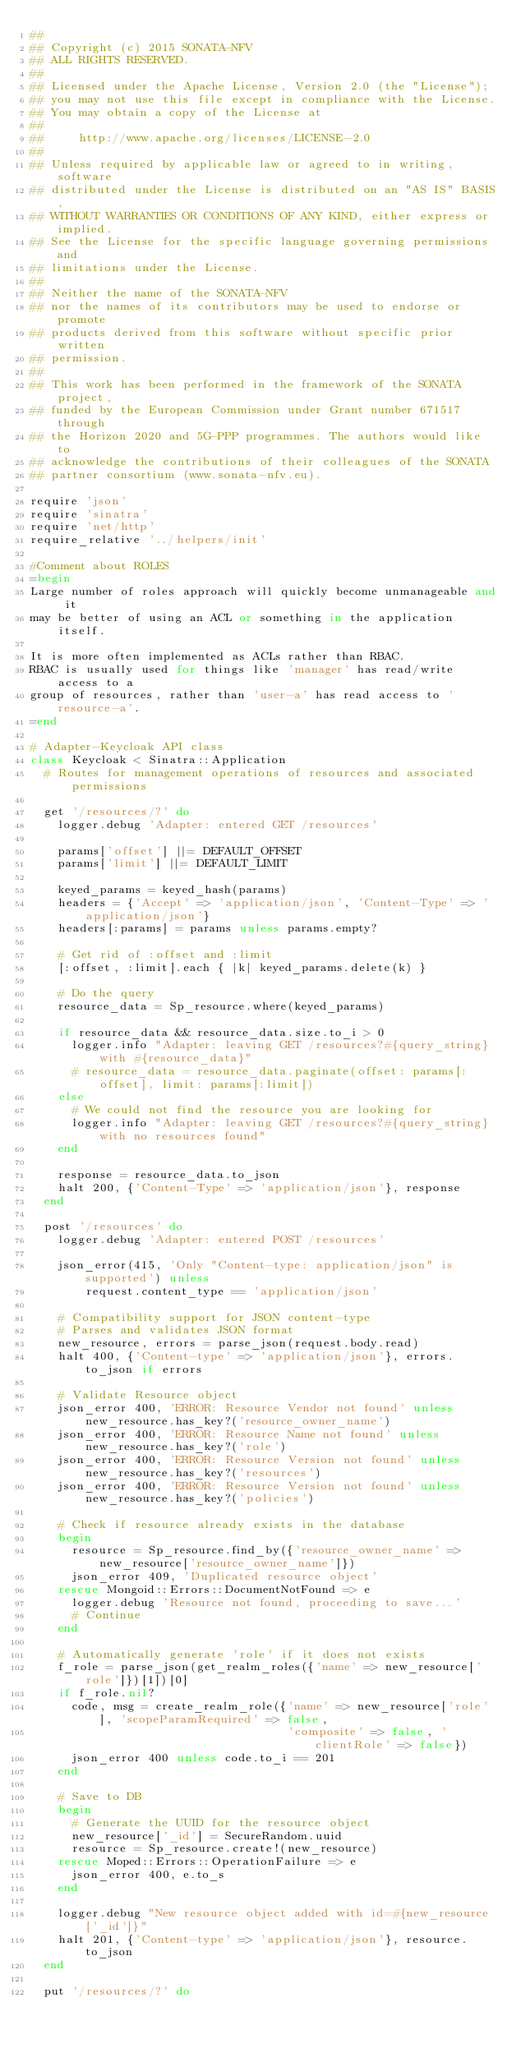<code> <loc_0><loc_0><loc_500><loc_500><_Ruby_>##
## Copyright (c) 2015 SONATA-NFV
## ALL RIGHTS RESERVED.
##
## Licensed under the Apache License, Version 2.0 (the "License");
## you may not use this file except in compliance with the License.
## You may obtain a copy of the License at
##
##     http://www.apache.org/licenses/LICENSE-2.0
##
## Unless required by applicable law or agreed to in writing, software
## distributed under the License is distributed on an "AS IS" BASIS,
## WITHOUT WARRANTIES OR CONDITIONS OF ANY KIND, either express or implied.
## See the License for the specific language governing permissions and
## limitations under the License.
##
## Neither the name of the SONATA-NFV
## nor the names of its contributors may be used to endorse or promote
## products derived from this software without specific prior written
## permission.
##
## This work has been performed in the framework of the SONATA project,
## funded by the European Commission under Grant number 671517 through
## the Horizon 2020 and 5G-PPP programmes. The authors would like to
## acknowledge the contributions of their colleagues of the SONATA
## partner consortium (www.sonata-nfv.eu).

require 'json'
require 'sinatra'
require 'net/http'
require_relative '../helpers/init'

#Comment about ROLES
=begin
Large number of roles approach will quickly become unmanageable and it
may be better of using an ACL or something in the application itself.

It is more often implemented as ACLs rather than RBAC.
RBAC is usually used for things like 'manager' has read/write access to a
group of resources, rather than 'user-a' has read access to 'resource-a'.
=end

# Adapter-Keycloak API class
class Keycloak < Sinatra::Application
  # Routes for management operations of resources and associated permissions

  get '/resources/?' do
    logger.debug 'Adapter: entered GET /resources'

    params['offset'] ||= DEFAULT_OFFSET
    params['limit'] ||= DEFAULT_LIMIT

    keyed_params = keyed_hash(params)
    headers = {'Accept' => 'application/json', 'Content-Type' => 'application/json'}
    headers[:params] = params unless params.empty?

    # Get rid of :offset and :limit
    [:offset, :limit].each { |k| keyed_params.delete(k) }

    # Do the query
    resource_data = Sp_resource.where(keyed_params)

    if resource_data && resource_data.size.to_i > 0
      logger.info "Adapter: leaving GET /resources?#{query_string} with #{resource_data}"
      # resource_data = resource_data.paginate(offset: params[:offset], limit: params[:limit])
    else
      # We could not find the resource you are looking for
      logger.info "Adapter: leaving GET /resources?#{query_string} with no resources found"
    end

    response = resource_data.to_json
    halt 200, {'Content-Type' => 'application/json'}, response
  end

  post '/resources' do
    logger.debug 'Adapter: entered POST /resources'

    json_error(415, 'Only "Content-type: application/json" is supported') unless
        request.content_type == 'application/json'

    # Compatibility support for JSON content-type
    # Parses and validates JSON format
    new_resource, errors = parse_json(request.body.read)
    halt 400, {'Content-type' => 'application/json'}, errors.to_json if errors

    # Validate Resource object
    json_error 400, 'ERROR: Resource Vendor not found' unless new_resource.has_key?('resource_owner_name')
    json_error 400, 'ERROR: Resource Name not found' unless new_resource.has_key?('role')
    json_error 400, 'ERROR: Resource Version not found' unless new_resource.has_key?('resources')
    json_error 400, 'ERROR: Resource Version not found' unless new_resource.has_key?('policies')

    # Check if resource already exists in the database
    begin
      resource = Sp_resource.find_by({'resource_owner_name' => new_resource['resource_owner_name']})
      json_error 409, 'Duplicated resource object'
    rescue Mongoid::Errors::DocumentNotFound => e
      logger.debug 'Resource not found, proceeding to save...'
      # Continue
    end

    # Automatically generate 'role' if it does not exists
    f_role = parse_json(get_realm_roles({'name' => new_resource['role']})[1])[0]
    if f_role.nil?
      code, msg = create_realm_role({'name' => new_resource['role'], 'scopeParamRequired' => false,
                                     'composite' => false, 'clientRole' => false})
      json_error 400 unless code.to_i == 201
    end

    # Save to DB
    begin
      # Generate the UUID for the resource object
      new_resource['_id'] = SecureRandom.uuid
      resource = Sp_resource.create!(new_resource)
    rescue Moped::Errors::OperationFailure => e
      json_error 400, e.to_s
    end

    logger.debug "New resource object added with id=#{new_resource['_id']}"
    halt 201, {'Content-type' => 'application/json'}, resource.to_json
  end

  put '/resources/?' do</code> 